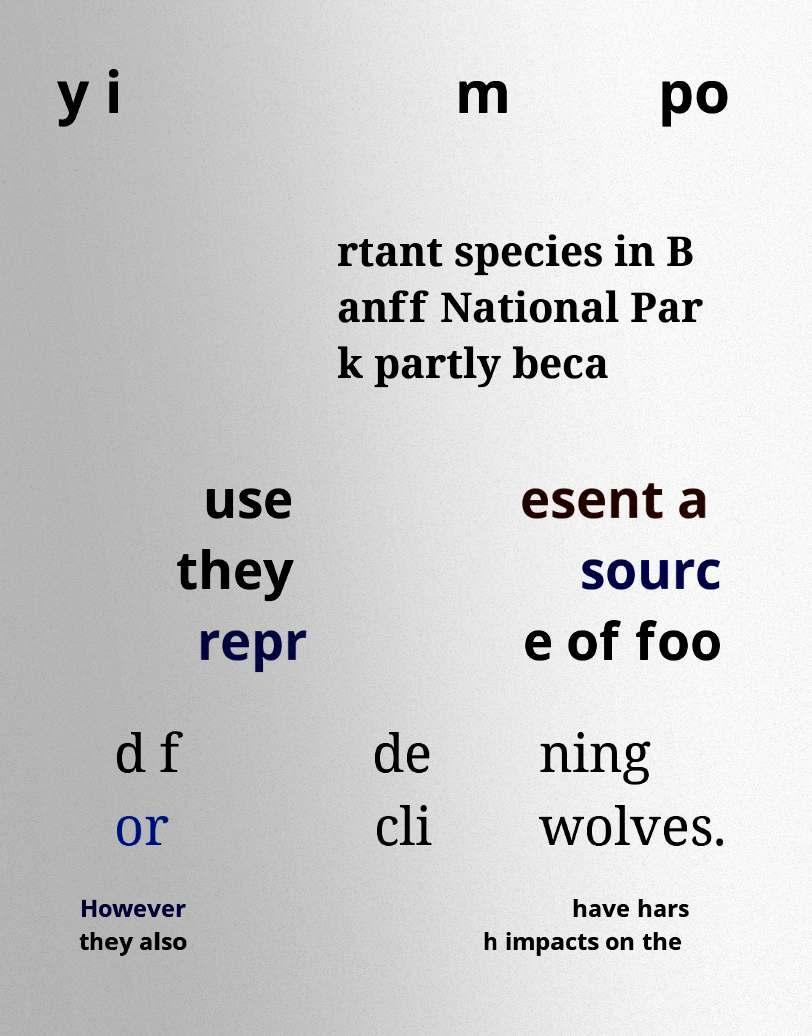For documentation purposes, I need the text within this image transcribed. Could you provide that? y i m po rtant species in B anff National Par k partly beca use they repr esent a sourc e of foo d f or de cli ning wolves. However they also have hars h impacts on the 